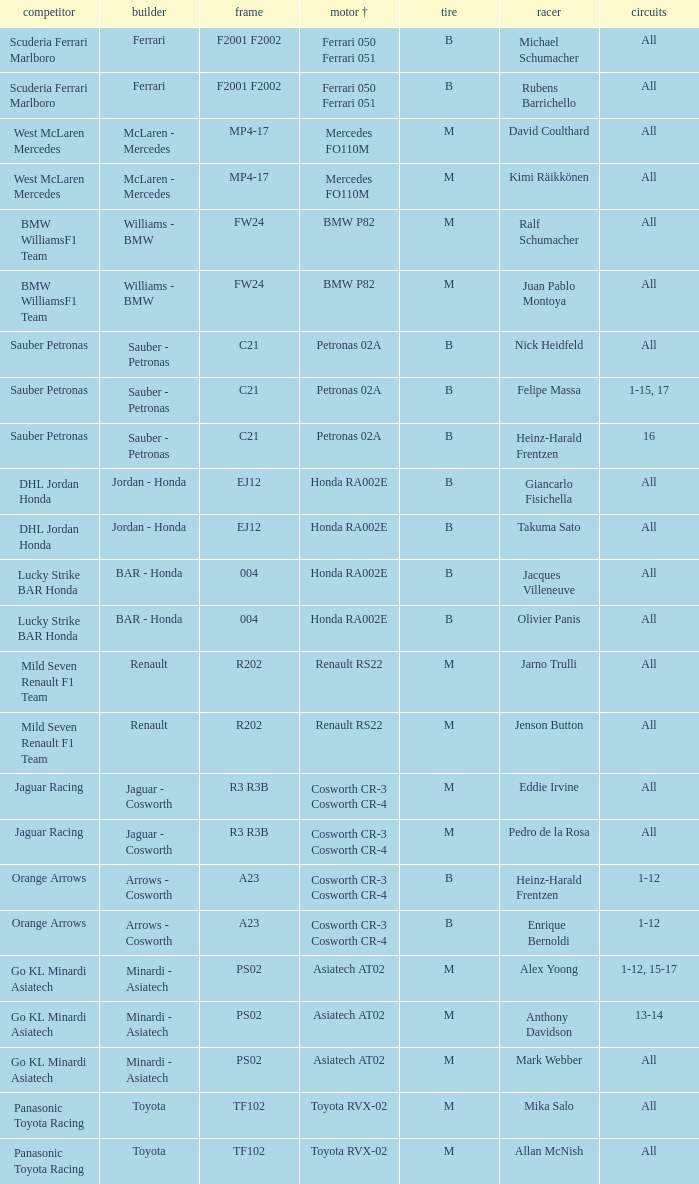What is the chassis when the tyre is b, the engine is ferrari 050 ferrari 051 and the driver is rubens barrichello? F2001 F2002. 